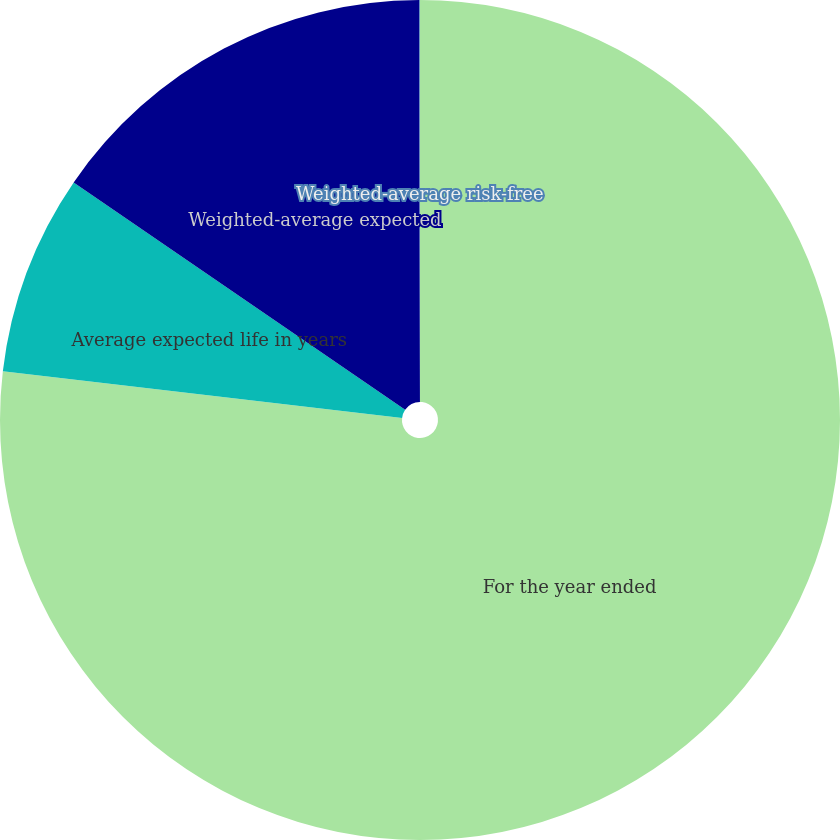<chart> <loc_0><loc_0><loc_500><loc_500><pie_chart><fcel>For the year ended<fcel>Average expected life in years<fcel>Weighted-average expected<fcel>Weighted-average risk-free<nl><fcel>76.85%<fcel>7.72%<fcel>15.4%<fcel>0.03%<nl></chart> 